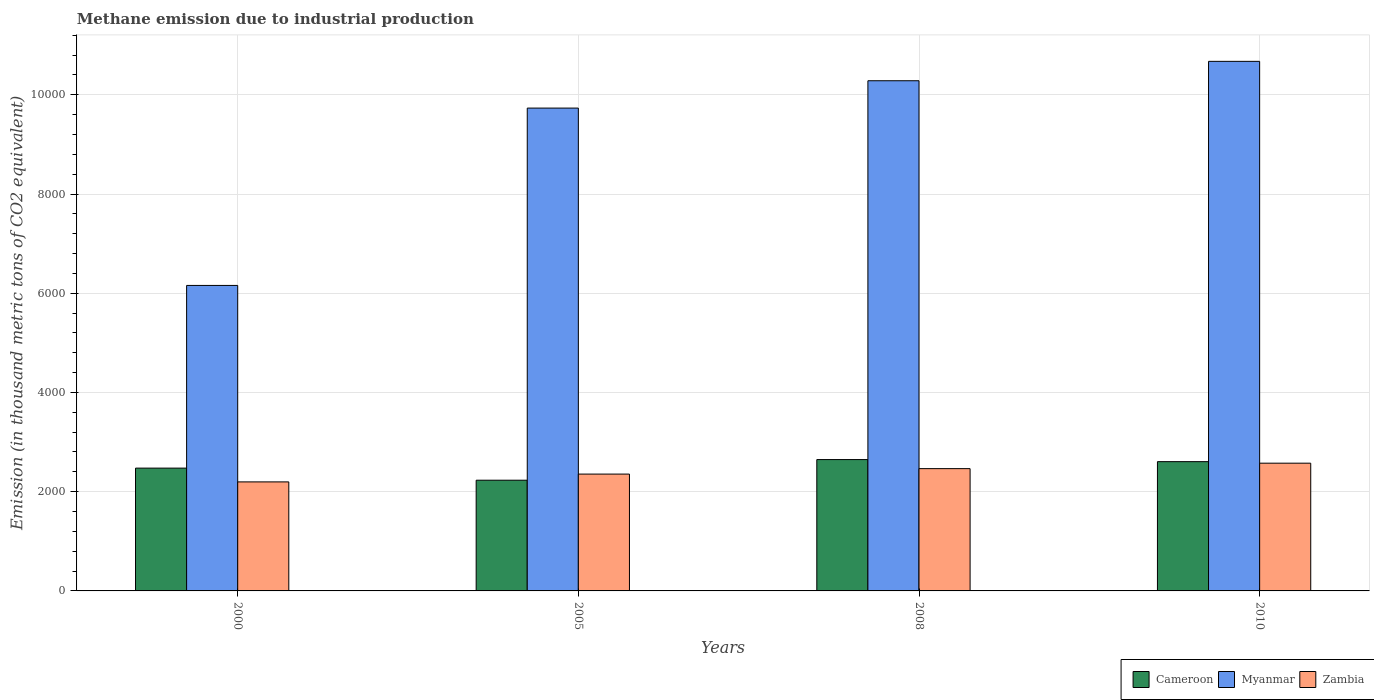How many bars are there on the 1st tick from the left?
Your response must be concise. 3. What is the amount of methane emitted in Zambia in 2008?
Provide a succinct answer. 2464.9. Across all years, what is the maximum amount of methane emitted in Myanmar?
Provide a short and direct response. 1.07e+04. Across all years, what is the minimum amount of methane emitted in Zambia?
Your response must be concise. 2197.5. In which year was the amount of methane emitted in Zambia minimum?
Your answer should be very brief. 2000. What is the total amount of methane emitted in Zambia in the graph?
Ensure brevity in your answer.  9592.1. What is the difference between the amount of methane emitted in Cameroon in 2000 and that in 2005?
Ensure brevity in your answer.  243.7. What is the difference between the amount of methane emitted in Myanmar in 2000 and the amount of methane emitted in Cameroon in 2008?
Ensure brevity in your answer.  3510.1. What is the average amount of methane emitted in Zambia per year?
Give a very brief answer. 2398.02. In the year 2000, what is the difference between the amount of methane emitted in Myanmar and amount of methane emitted in Cameroon?
Ensure brevity in your answer.  3682.3. What is the ratio of the amount of methane emitted in Zambia in 2005 to that in 2008?
Make the answer very short. 0.96. What is the difference between the highest and the second highest amount of methane emitted in Cameroon?
Offer a very short reply. 41.9. What is the difference between the highest and the lowest amount of methane emitted in Cameroon?
Your answer should be very brief. 415.9. In how many years, is the amount of methane emitted in Myanmar greater than the average amount of methane emitted in Myanmar taken over all years?
Provide a short and direct response. 3. Is the sum of the amount of methane emitted in Zambia in 2000 and 2008 greater than the maximum amount of methane emitted in Myanmar across all years?
Offer a terse response. No. What does the 1st bar from the left in 2005 represents?
Provide a short and direct response. Cameroon. What does the 1st bar from the right in 2008 represents?
Provide a succinct answer. Zambia. Are all the bars in the graph horizontal?
Your answer should be very brief. No. What is the difference between two consecutive major ticks on the Y-axis?
Keep it short and to the point. 2000. Are the values on the major ticks of Y-axis written in scientific E-notation?
Your answer should be compact. No. How many legend labels are there?
Ensure brevity in your answer.  3. How are the legend labels stacked?
Your answer should be very brief. Horizontal. What is the title of the graph?
Offer a very short reply. Methane emission due to industrial production. Does "Colombia" appear as one of the legend labels in the graph?
Provide a succinct answer. No. What is the label or title of the Y-axis?
Provide a succinct answer. Emission (in thousand metric tons of CO2 equivalent). What is the Emission (in thousand metric tons of CO2 equivalent) in Cameroon in 2000?
Ensure brevity in your answer.  2475.1. What is the Emission (in thousand metric tons of CO2 equivalent) in Myanmar in 2000?
Provide a short and direct response. 6157.4. What is the Emission (in thousand metric tons of CO2 equivalent) of Zambia in 2000?
Provide a short and direct response. 2197.5. What is the Emission (in thousand metric tons of CO2 equivalent) in Cameroon in 2005?
Offer a terse response. 2231.4. What is the Emission (in thousand metric tons of CO2 equivalent) of Myanmar in 2005?
Your response must be concise. 9731.7. What is the Emission (in thousand metric tons of CO2 equivalent) of Zambia in 2005?
Keep it short and to the point. 2355. What is the Emission (in thousand metric tons of CO2 equivalent) in Cameroon in 2008?
Offer a very short reply. 2647.3. What is the Emission (in thousand metric tons of CO2 equivalent) in Myanmar in 2008?
Make the answer very short. 1.03e+04. What is the Emission (in thousand metric tons of CO2 equivalent) in Zambia in 2008?
Your answer should be compact. 2464.9. What is the Emission (in thousand metric tons of CO2 equivalent) in Cameroon in 2010?
Ensure brevity in your answer.  2605.4. What is the Emission (in thousand metric tons of CO2 equivalent) of Myanmar in 2010?
Ensure brevity in your answer.  1.07e+04. What is the Emission (in thousand metric tons of CO2 equivalent) of Zambia in 2010?
Keep it short and to the point. 2574.7. Across all years, what is the maximum Emission (in thousand metric tons of CO2 equivalent) of Cameroon?
Offer a terse response. 2647.3. Across all years, what is the maximum Emission (in thousand metric tons of CO2 equivalent) of Myanmar?
Keep it short and to the point. 1.07e+04. Across all years, what is the maximum Emission (in thousand metric tons of CO2 equivalent) of Zambia?
Offer a terse response. 2574.7. Across all years, what is the minimum Emission (in thousand metric tons of CO2 equivalent) in Cameroon?
Your response must be concise. 2231.4. Across all years, what is the minimum Emission (in thousand metric tons of CO2 equivalent) in Myanmar?
Provide a short and direct response. 6157.4. Across all years, what is the minimum Emission (in thousand metric tons of CO2 equivalent) of Zambia?
Provide a short and direct response. 2197.5. What is the total Emission (in thousand metric tons of CO2 equivalent) of Cameroon in the graph?
Your response must be concise. 9959.2. What is the total Emission (in thousand metric tons of CO2 equivalent) of Myanmar in the graph?
Keep it short and to the point. 3.68e+04. What is the total Emission (in thousand metric tons of CO2 equivalent) of Zambia in the graph?
Keep it short and to the point. 9592.1. What is the difference between the Emission (in thousand metric tons of CO2 equivalent) of Cameroon in 2000 and that in 2005?
Provide a short and direct response. 243.7. What is the difference between the Emission (in thousand metric tons of CO2 equivalent) in Myanmar in 2000 and that in 2005?
Provide a succinct answer. -3574.3. What is the difference between the Emission (in thousand metric tons of CO2 equivalent) of Zambia in 2000 and that in 2005?
Keep it short and to the point. -157.5. What is the difference between the Emission (in thousand metric tons of CO2 equivalent) of Cameroon in 2000 and that in 2008?
Make the answer very short. -172.2. What is the difference between the Emission (in thousand metric tons of CO2 equivalent) in Myanmar in 2000 and that in 2008?
Your answer should be very brief. -4125.3. What is the difference between the Emission (in thousand metric tons of CO2 equivalent) of Zambia in 2000 and that in 2008?
Provide a succinct answer. -267.4. What is the difference between the Emission (in thousand metric tons of CO2 equivalent) of Cameroon in 2000 and that in 2010?
Make the answer very short. -130.3. What is the difference between the Emission (in thousand metric tons of CO2 equivalent) of Myanmar in 2000 and that in 2010?
Give a very brief answer. -4516.2. What is the difference between the Emission (in thousand metric tons of CO2 equivalent) in Zambia in 2000 and that in 2010?
Offer a terse response. -377.2. What is the difference between the Emission (in thousand metric tons of CO2 equivalent) of Cameroon in 2005 and that in 2008?
Keep it short and to the point. -415.9. What is the difference between the Emission (in thousand metric tons of CO2 equivalent) of Myanmar in 2005 and that in 2008?
Keep it short and to the point. -551. What is the difference between the Emission (in thousand metric tons of CO2 equivalent) in Zambia in 2005 and that in 2008?
Offer a very short reply. -109.9. What is the difference between the Emission (in thousand metric tons of CO2 equivalent) in Cameroon in 2005 and that in 2010?
Your answer should be compact. -374. What is the difference between the Emission (in thousand metric tons of CO2 equivalent) of Myanmar in 2005 and that in 2010?
Keep it short and to the point. -941.9. What is the difference between the Emission (in thousand metric tons of CO2 equivalent) of Zambia in 2005 and that in 2010?
Give a very brief answer. -219.7. What is the difference between the Emission (in thousand metric tons of CO2 equivalent) in Cameroon in 2008 and that in 2010?
Provide a short and direct response. 41.9. What is the difference between the Emission (in thousand metric tons of CO2 equivalent) in Myanmar in 2008 and that in 2010?
Your response must be concise. -390.9. What is the difference between the Emission (in thousand metric tons of CO2 equivalent) of Zambia in 2008 and that in 2010?
Offer a terse response. -109.8. What is the difference between the Emission (in thousand metric tons of CO2 equivalent) in Cameroon in 2000 and the Emission (in thousand metric tons of CO2 equivalent) in Myanmar in 2005?
Your response must be concise. -7256.6. What is the difference between the Emission (in thousand metric tons of CO2 equivalent) in Cameroon in 2000 and the Emission (in thousand metric tons of CO2 equivalent) in Zambia in 2005?
Make the answer very short. 120.1. What is the difference between the Emission (in thousand metric tons of CO2 equivalent) in Myanmar in 2000 and the Emission (in thousand metric tons of CO2 equivalent) in Zambia in 2005?
Make the answer very short. 3802.4. What is the difference between the Emission (in thousand metric tons of CO2 equivalent) of Cameroon in 2000 and the Emission (in thousand metric tons of CO2 equivalent) of Myanmar in 2008?
Give a very brief answer. -7807.6. What is the difference between the Emission (in thousand metric tons of CO2 equivalent) in Myanmar in 2000 and the Emission (in thousand metric tons of CO2 equivalent) in Zambia in 2008?
Ensure brevity in your answer.  3692.5. What is the difference between the Emission (in thousand metric tons of CO2 equivalent) of Cameroon in 2000 and the Emission (in thousand metric tons of CO2 equivalent) of Myanmar in 2010?
Your response must be concise. -8198.5. What is the difference between the Emission (in thousand metric tons of CO2 equivalent) in Cameroon in 2000 and the Emission (in thousand metric tons of CO2 equivalent) in Zambia in 2010?
Give a very brief answer. -99.6. What is the difference between the Emission (in thousand metric tons of CO2 equivalent) of Myanmar in 2000 and the Emission (in thousand metric tons of CO2 equivalent) of Zambia in 2010?
Give a very brief answer. 3582.7. What is the difference between the Emission (in thousand metric tons of CO2 equivalent) in Cameroon in 2005 and the Emission (in thousand metric tons of CO2 equivalent) in Myanmar in 2008?
Ensure brevity in your answer.  -8051.3. What is the difference between the Emission (in thousand metric tons of CO2 equivalent) in Cameroon in 2005 and the Emission (in thousand metric tons of CO2 equivalent) in Zambia in 2008?
Offer a terse response. -233.5. What is the difference between the Emission (in thousand metric tons of CO2 equivalent) of Myanmar in 2005 and the Emission (in thousand metric tons of CO2 equivalent) of Zambia in 2008?
Your response must be concise. 7266.8. What is the difference between the Emission (in thousand metric tons of CO2 equivalent) in Cameroon in 2005 and the Emission (in thousand metric tons of CO2 equivalent) in Myanmar in 2010?
Give a very brief answer. -8442.2. What is the difference between the Emission (in thousand metric tons of CO2 equivalent) in Cameroon in 2005 and the Emission (in thousand metric tons of CO2 equivalent) in Zambia in 2010?
Offer a very short reply. -343.3. What is the difference between the Emission (in thousand metric tons of CO2 equivalent) of Myanmar in 2005 and the Emission (in thousand metric tons of CO2 equivalent) of Zambia in 2010?
Offer a terse response. 7157. What is the difference between the Emission (in thousand metric tons of CO2 equivalent) of Cameroon in 2008 and the Emission (in thousand metric tons of CO2 equivalent) of Myanmar in 2010?
Provide a succinct answer. -8026.3. What is the difference between the Emission (in thousand metric tons of CO2 equivalent) of Cameroon in 2008 and the Emission (in thousand metric tons of CO2 equivalent) of Zambia in 2010?
Give a very brief answer. 72.6. What is the difference between the Emission (in thousand metric tons of CO2 equivalent) in Myanmar in 2008 and the Emission (in thousand metric tons of CO2 equivalent) in Zambia in 2010?
Ensure brevity in your answer.  7708. What is the average Emission (in thousand metric tons of CO2 equivalent) of Cameroon per year?
Offer a terse response. 2489.8. What is the average Emission (in thousand metric tons of CO2 equivalent) in Myanmar per year?
Provide a short and direct response. 9211.35. What is the average Emission (in thousand metric tons of CO2 equivalent) in Zambia per year?
Provide a short and direct response. 2398.03. In the year 2000, what is the difference between the Emission (in thousand metric tons of CO2 equivalent) of Cameroon and Emission (in thousand metric tons of CO2 equivalent) of Myanmar?
Your answer should be very brief. -3682.3. In the year 2000, what is the difference between the Emission (in thousand metric tons of CO2 equivalent) in Cameroon and Emission (in thousand metric tons of CO2 equivalent) in Zambia?
Ensure brevity in your answer.  277.6. In the year 2000, what is the difference between the Emission (in thousand metric tons of CO2 equivalent) of Myanmar and Emission (in thousand metric tons of CO2 equivalent) of Zambia?
Keep it short and to the point. 3959.9. In the year 2005, what is the difference between the Emission (in thousand metric tons of CO2 equivalent) in Cameroon and Emission (in thousand metric tons of CO2 equivalent) in Myanmar?
Ensure brevity in your answer.  -7500.3. In the year 2005, what is the difference between the Emission (in thousand metric tons of CO2 equivalent) of Cameroon and Emission (in thousand metric tons of CO2 equivalent) of Zambia?
Provide a succinct answer. -123.6. In the year 2005, what is the difference between the Emission (in thousand metric tons of CO2 equivalent) in Myanmar and Emission (in thousand metric tons of CO2 equivalent) in Zambia?
Keep it short and to the point. 7376.7. In the year 2008, what is the difference between the Emission (in thousand metric tons of CO2 equivalent) of Cameroon and Emission (in thousand metric tons of CO2 equivalent) of Myanmar?
Your response must be concise. -7635.4. In the year 2008, what is the difference between the Emission (in thousand metric tons of CO2 equivalent) in Cameroon and Emission (in thousand metric tons of CO2 equivalent) in Zambia?
Ensure brevity in your answer.  182.4. In the year 2008, what is the difference between the Emission (in thousand metric tons of CO2 equivalent) in Myanmar and Emission (in thousand metric tons of CO2 equivalent) in Zambia?
Give a very brief answer. 7817.8. In the year 2010, what is the difference between the Emission (in thousand metric tons of CO2 equivalent) in Cameroon and Emission (in thousand metric tons of CO2 equivalent) in Myanmar?
Provide a succinct answer. -8068.2. In the year 2010, what is the difference between the Emission (in thousand metric tons of CO2 equivalent) in Cameroon and Emission (in thousand metric tons of CO2 equivalent) in Zambia?
Provide a short and direct response. 30.7. In the year 2010, what is the difference between the Emission (in thousand metric tons of CO2 equivalent) of Myanmar and Emission (in thousand metric tons of CO2 equivalent) of Zambia?
Ensure brevity in your answer.  8098.9. What is the ratio of the Emission (in thousand metric tons of CO2 equivalent) of Cameroon in 2000 to that in 2005?
Your response must be concise. 1.11. What is the ratio of the Emission (in thousand metric tons of CO2 equivalent) of Myanmar in 2000 to that in 2005?
Offer a terse response. 0.63. What is the ratio of the Emission (in thousand metric tons of CO2 equivalent) in Zambia in 2000 to that in 2005?
Ensure brevity in your answer.  0.93. What is the ratio of the Emission (in thousand metric tons of CO2 equivalent) in Cameroon in 2000 to that in 2008?
Offer a terse response. 0.94. What is the ratio of the Emission (in thousand metric tons of CO2 equivalent) of Myanmar in 2000 to that in 2008?
Your answer should be compact. 0.6. What is the ratio of the Emission (in thousand metric tons of CO2 equivalent) of Zambia in 2000 to that in 2008?
Provide a short and direct response. 0.89. What is the ratio of the Emission (in thousand metric tons of CO2 equivalent) in Myanmar in 2000 to that in 2010?
Provide a short and direct response. 0.58. What is the ratio of the Emission (in thousand metric tons of CO2 equivalent) of Zambia in 2000 to that in 2010?
Your answer should be very brief. 0.85. What is the ratio of the Emission (in thousand metric tons of CO2 equivalent) of Cameroon in 2005 to that in 2008?
Give a very brief answer. 0.84. What is the ratio of the Emission (in thousand metric tons of CO2 equivalent) of Myanmar in 2005 to that in 2008?
Your answer should be compact. 0.95. What is the ratio of the Emission (in thousand metric tons of CO2 equivalent) of Zambia in 2005 to that in 2008?
Your answer should be very brief. 0.96. What is the ratio of the Emission (in thousand metric tons of CO2 equivalent) in Cameroon in 2005 to that in 2010?
Your answer should be compact. 0.86. What is the ratio of the Emission (in thousand metric tons of CO2 equivalent) in Myanmar in 2005 to that in 2010?
Your answer should be very brief. 0.91. What is the ratio of the Emission (in thousand metric tons of CO2 equivalent) of Zambia in 2005 to that in 2010?
Ensure brevity in your answer.  0.91. What is the ratio of the Emission (in thousand metric tons of CO2 equivalent) in Cameroon in 2008 to that in 2010?
Provide a short and direct response. 1.02. What is the ratio of the Emission (in thousand metric tons of CO2 equivalent) in Myanmar in 2008 to that in 2010?
Offer a terse response. 0.96. What is the ratio of the Emission (in thousand metric tons of CO2 equivalent) of Zambia in 2008 to that in 2010?
Provide a succinct answer. 0.96. What is the difference between the highest and the second highest Emission (in thousand metric tons of CO2 equivalent) of Cameroon?
Ensure brevity in your answer.  41.9. What is the difference between the highest and the second highest Emission (in thousand metric tons of CO2 equivalent) of Myanmar?
Offer a very short reply. 390.9. What is the difference between the highest and the second highest Emission (in thousand metric tons of CO2 equivalent) in Zambia?
Make the answer very short. 109.8. What is the difference between the highest and the lowest Emission (in thousand metric tons of CO2 equivalent) of Cameroon?
Keep it short and to the point. 415.9. What is the difference between the highest and the lowest Emission (in thousand metric tons of CO2 equivalent) in Myanmar?
Your answer should be compact. 4516.2. What is the difference between the highest and the lowest Emission (in thousand metric tons of CO2 equivalent) of Zambia?
Give a very brief answer. 377.2. 